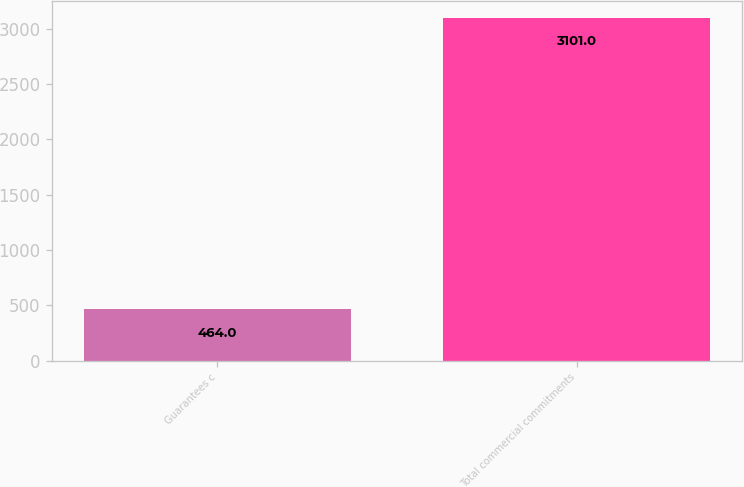Convert chart to OTSL. <chart><loc_0><loc_0><loc_500><loc_500><bar_chart><fcel>Guarantees c<fcel>Total commercial commitments<nl><fcel>464<fcel>3101<nl></chart> 